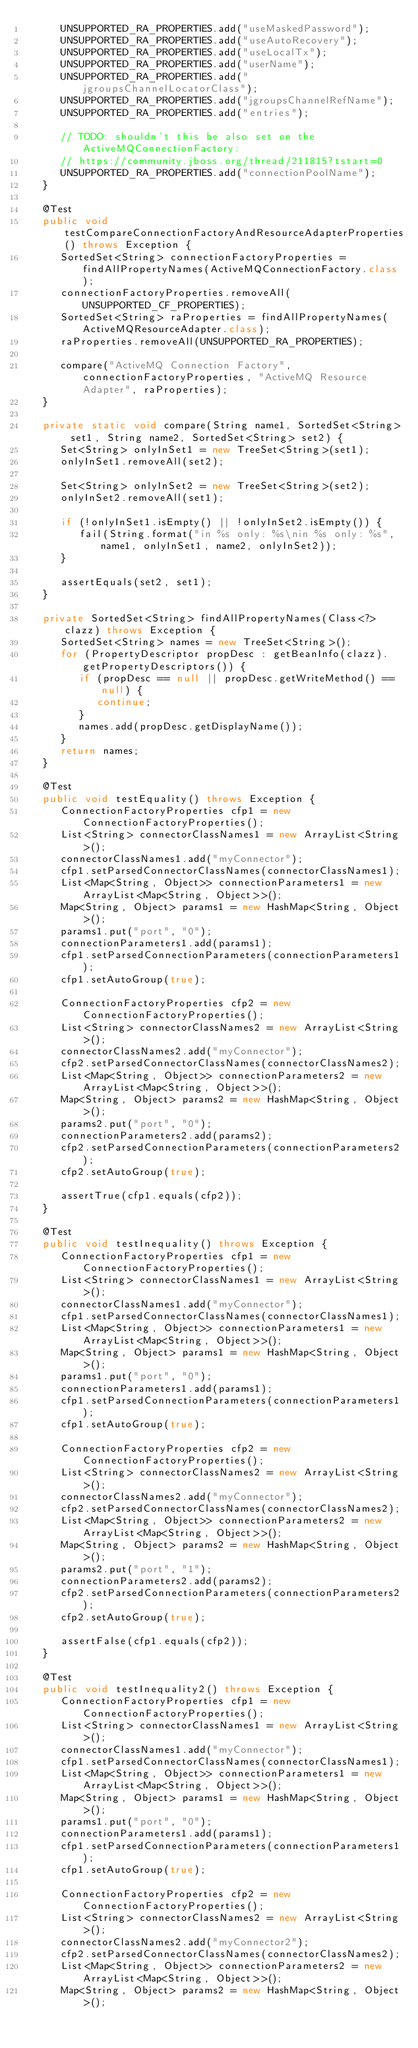<code> <loc_0><loc_0><loc_500><loc_500><_Java_>      UNSUPPORTED_RA_PROPERTIES.add("useMaskedPassword");
      UNSUPPORTED_RA_PROPERTIES.add("useAutoRecovery");
      UNSUPPORTED_RA_PROPERTIES.add("useLocalTx");
      UNSUPPORTED_RA_PROPERTIES.add("userName");
      UNSUPPORTED_RA_PROPERTIES.add("jgroupsChannelLocatorClass");
      UNSUPPORTED_RA_PROPERTIES.add("jgroupsChannelRefName");
      UNSUPPORTED_RA_PROPERTIES.add("entries");

      // TODO: shouldn't this be also set on the ActiveMQConnectionFactory:
      // https://community.jboss.org/thread/211815?tstart=0
      UNSUPPORTED_RA_PROPERTIES.add("connectionPoolName");
   }

   @Test
   public void testCompareConnectionFactoryAndResourceAdapterProperties() throws Exception {
      SortedSet<String> connectionFactoryProperties = findAllPropertyNames(ActiveMQConnectionFactory.class);
      connectionFactoryProperties.removeAll(UNSUPPORTED_CF_PROPERTIES);
      SortedSet<String> raProperties = findAllPropertyNames(ActiveMQResourceAdapter.class);
      raProperties.removeAll(UNSUPPORTED_RA_PROPERTIES);

      compare("ActiveMQ Connection Factory", connectionFactoryProperties, "ActiveMQ Resource Adapter", raProperties);
   }

   private static void compare(String name1, SortedSet<String> set1, String name2, SortedSet<String> set2) {
      Set<String> onlyInSet1 = new TreeSet<String>(set1);
      onlyInSet1.removeAll(set2);

      Set<String> onlyInSet2 = new TreeSet<String>(set2);
      onlyInSet2.removeAll(set1);

      if (!onlyInSet1.isEmpty() || !onlyInSet2.isEmpty()) {
         fail(String.format("in %s only: %s\nin %s only: %s", name1, onlyInSet1, name2, onlyInSet2));
      }

      assertEquals(set2, set1);
   }

   private SortedSet<String> findAllPropertyNames(Class<?> clazz) throws Exception {
      SortedSet<String> names = new TreeSet<String>();
      for (PropertyDescriptor propDesc : getBeanInfo(clazz).getPropertyDescriptors()) {
         if (propDesc == null || propDesc.getWriteMethod() == null) {
            continue;
         }
         names.add(propDesc.getDisplayName());
      }
      return names;
   }

   @Test
   public void testEquality() throws Exception {
      ConnectionFactoryProperties cfp1 = new ConnectionFactoryProperties();
      List<String> connectorClassNames1 = new ArrayList<String>();
      connectorClassNames1.add("myConnector");
      cfp1.setParsedConnectorClassNames(connectorClassNames1);
      List<Map<String, Object>> connectionParameters1 = new ArrayList<Map<String, Object>>();
      Map<String, Object> params1 = new HashMap<String, Object>();
      params1.put("port", "0");
      connectionParameters1.add(params1);
      cfp1.setParsedConnectionParameters(connectionParameters1);
      cfp1.setAutoGroup(true);

      ConnectionFactoryProperties cfp2 = new ConnectionFactoryProperties();
      List<String> connectorClassNames2 = new ArrayList<String>();
      connectorClassNames2.add("myConnector");
      cfp2.setParsedConnectorClassNames(connectorClassNames2);
      List<Map<String, Object>> connectionParameters2 = new ArrayList<Map<String, Object>>();
      Map<String, Object> params2 = new HashMap<String, Object>();
      params2.put("port", "0");
      connectionParameters2.add(params2);
      cfp2.setParsedConnectionParameters(connectionParameters2);
      cfp2.setAutoGroup(true);

      assertTrue(cfp1.equals(cfp2));
   }

   @Test
   public void testInequality() throws Exception {
      ConnectionFactoryProperties cfp1 = new ConnectionFactoryProperties();
      List<String> connectorClassNames1 = new ArrayList<String>();
      connectorClassNames1.add("myConnector");
      cfp1.setParsedConnectorClassNames(connectorClassNames1);
      List<Map<String, Object>> connectionParameters1 = new ArrayList<Map<String, Object>>();
      Map<String, Object> params1 = new HashMap<String, Object>();
      params1.put("port", "0");
      connectionParameters1.add(params1);
      cfp1.setParsedConnectionParameters(connectionParameters1);
      cfp1.setAutoGroup(true);

      ConnectionFactoryProperties cfp2 = new ConnectionFactoryProperties();
      List<String> connectorClassNames2 = new ArrayList<String>();
      connectorClassNames2.add("myConnector");
      cfp2.setParsedConnectorClassNames(connectorClassNames2);
      List<Map<String, Object>> connectionParameters2 = new ArrayList<Map<String, Object>>();
      Map<String, Object> params2 = new HashMap<String, Object>();
      params2.put("port", "1");
      connectionParameters2.add(params2);
      cfp2.setParsedConnectionParameters(connectionParameters2);
      cfp2.setAutoGroup(true);

      assertFalse(cfp1.equals(cfp2));
   }

   @Test
   public void testInequality2() throws Exception {
      ConnectionFactoryProperties cfp1 = new ConnectionFactoryProperties();
      List<String> connectorClassNames1 = new ArrayList<String>();
      connectorClassNames1.add("myConnector");
      cfp1.setParsedConnectorClassNames(connectorClassNames1);
      List<Map<String, Object>> connectionParameters1 = new ArrayList<Map<String, Object>>();
      Map<String, Object> params1 = new HashMap<String, Object>();
      params1.put("port", "0");
      connectionParameters1.add(params1);
      cfp1.setParsedConnectionParameters(connectionParameters1);
      cfp1.setAutoGroup(true);

      ConnectionFactoryProperties cfp2 = new ConnectionFactoryProperties();
      List<String> connectorClassNames2 = new ArrayList<String>();
      connectorClassNames2.add("myConnector2");
      cfp2.setParsedConnectorClassNames(connectorClassNames2);
      List<Map<String, Object>> connectionParameters2 = new ArrayList<Map<String, Object>>();
      Map<String, Object> params2 = new HashMap<String, Object>();</code> 